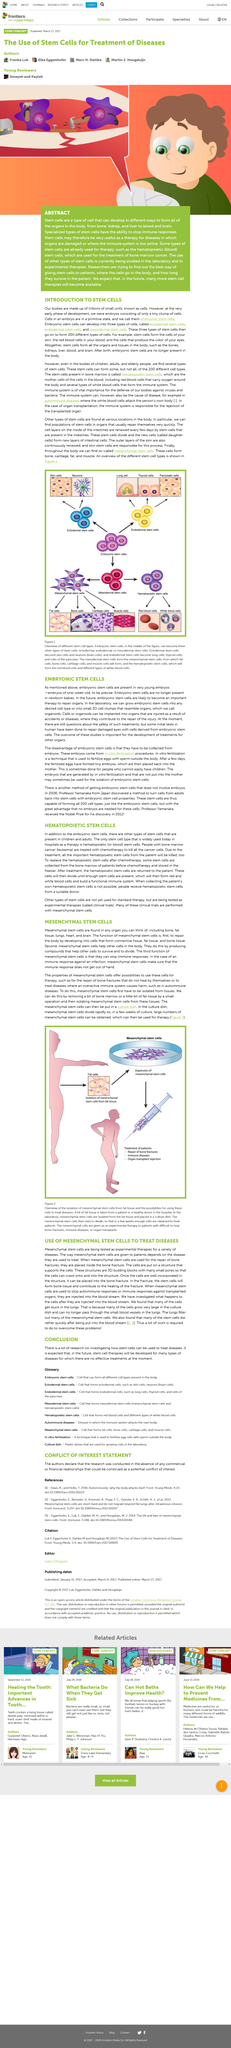Draw attention to some important aspects in this diagram. I declare that the phrase 'Embryonic Stem Cells' is used six times in this article including the title. Mesenchymal stem cells can be found in various tissues, including bone, fat, lung, heart, and brain. Embryonic stem cells have the potential to differentiate into three distinct cell types: ectodermal, endodermal, and mesodermal stem cells. Mesenchymal stem cells are the first line of defense against tissue damage and have the primary function of repairing the body. Embryonic stem cells are the cells that are present in an embryo. These cells are called embryonic stem cells. 